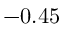Convert formula to latex. <formula><loc_0><loc_0><loc_500><loc_500>- 0 . 4 5</formula> 